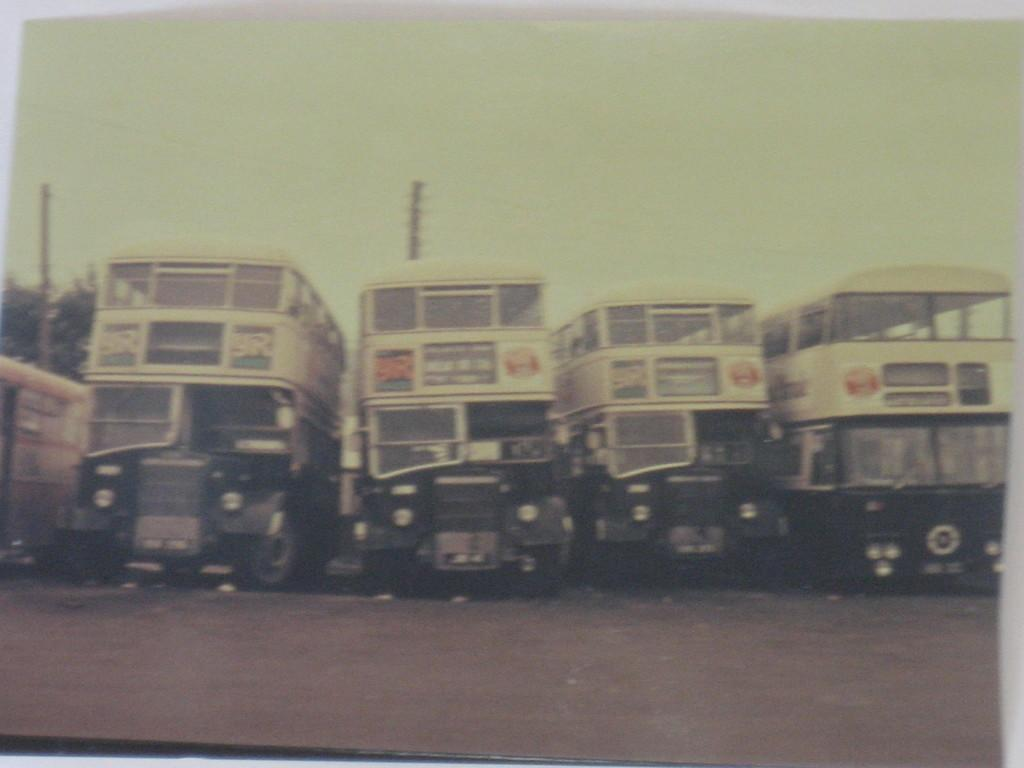How many buses are in the image? There are four double-decker buses in the image. What type of buses are in the image? The buses are double-decker buses. Can you describe the background of the image? There is a tree in the left corner of the image. What type of toys can be seen on the buses in the image? There are no toys visible on the buses in the image. Is there any snow present in the image? There is no snow present in the image. 